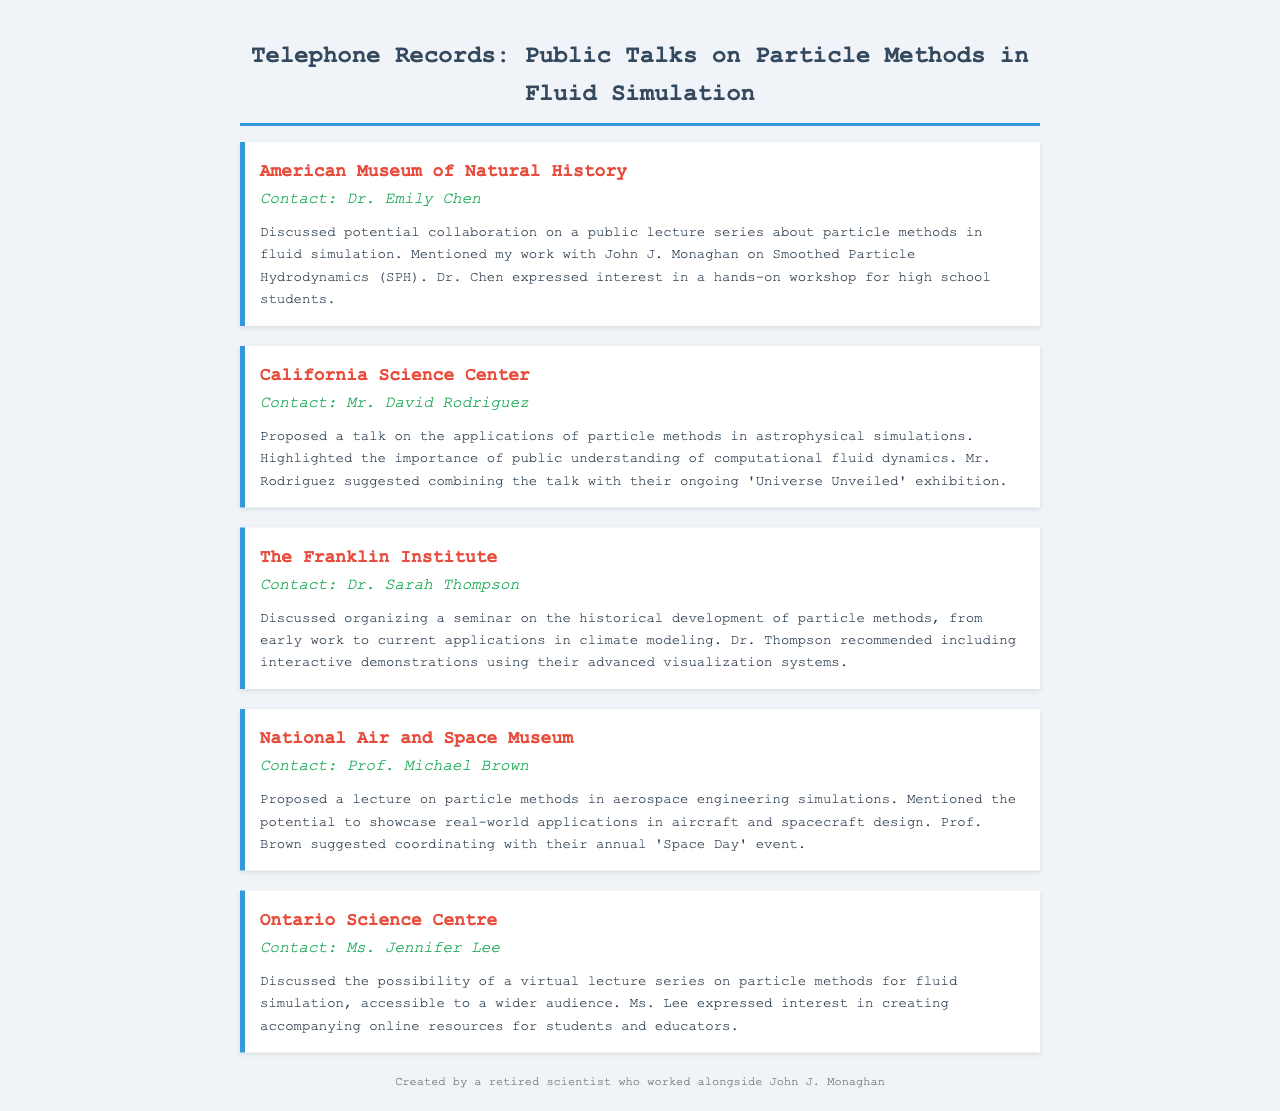What is the name of the first institution contacted? The document lists the institutions in the order they were contacted, starting with the American Museum of Natural History.
Answer: American Museum of Natural History Who did I speak to at the California Science Center? The contact person at the California Science Center is mentioned in the notes as Mr. David Rodriguez.
Answer: Mr. David Rodriguez What specific topic was proposed for the lecture at the National Air and Space Museum? The proposed lecture topic is outlined in the notes as focusing on particle methods in aerospace engineering simulations.
Answer: Particle methods in aerospace engineering simulations What type of event did Prof. Michael Brown suggest coordinating with? The preceding record specifies that the coordination suggestion relates to the National Air and Space Museum's annual 'Space Day' event.
Answer: Space Day What was one suggestion made by Dr. Sarah Thompson regarding the seminar? The note mentions that Dr. Thompson recommended including interactive demonstrations as part of the seminar.
Answer: Interactive demonstrations How many institutions are mentioned in the document? The document lists a total of five different institutions that were contacted.
Answer: Five What kind of lecture series did Ms. Jennifer Lee express interest in creating? The document notes that Ms. Lee was interested in a virtual lecture series on particle methods for fluid simulation.
Answer: Virtual lecture series Which institution is associated with Dr. Emily Chen? The first record identifies Dr. Emily Chen as the contact at the American Museum of Natural History.
Answer: American Museum of Natural History What is a common theme mentioned in discussions with several institutions? The common theme across multiple discussions includes organizing public talks or seminars related to particle methods in fluid simulation.
Answer: Public talks on particle methods in fluid simulation 